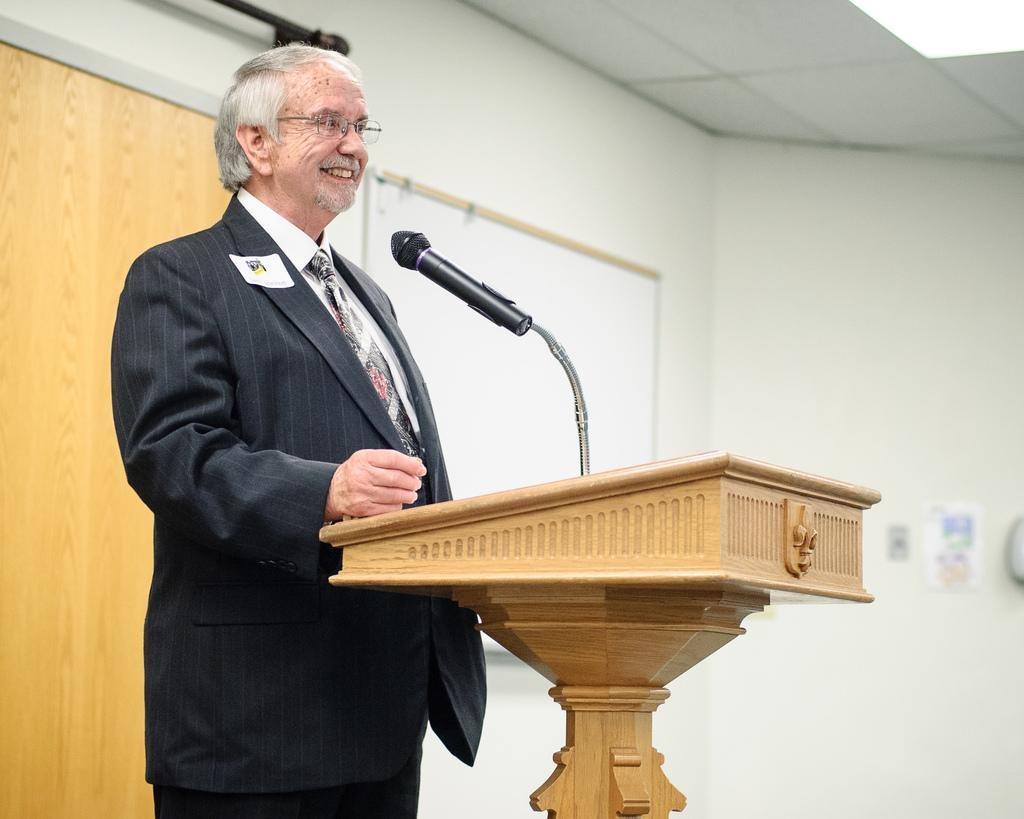Who is present in the image? There is a man in the image. What is the man doing in the image? The man is standing and smiling in the image. What is the man standing in front of? The man is in front of a podium. What is on the podium? There is a microphone on the podium. What can be seen in the background of the image? There is a wall and a board in the background of the image. What type of mitten is the man wearing in the image? There is no mitten present in the image; the man is not wearing any gloves or mittens. Can you tell me how many people are walking on the sidewalk in the image? There is no sidewalk present in the image, so it is not possible to determine how many people might be walking on it. 